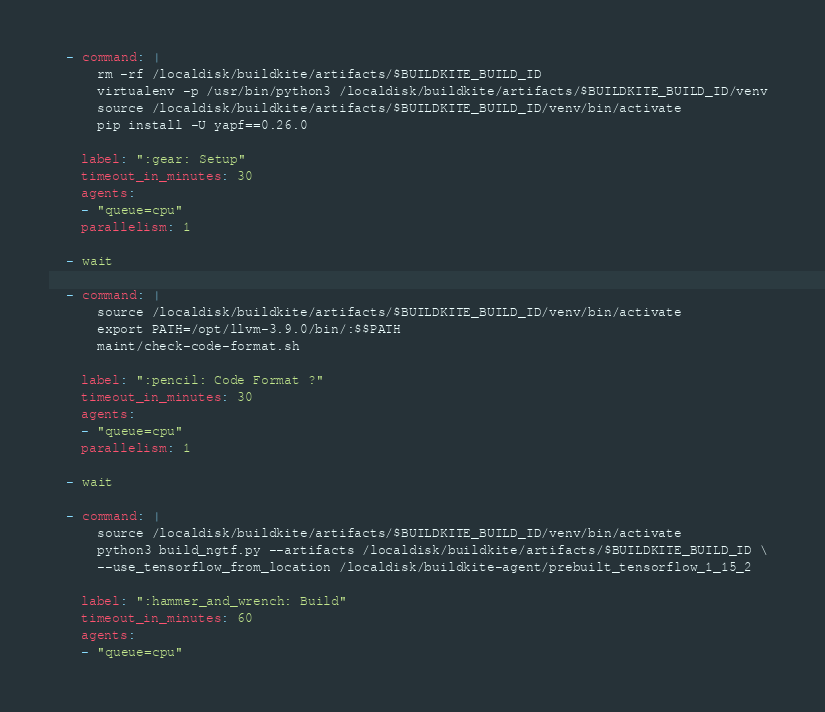<code> <loc_0><loc_0><loc_500><loc_500><_YAML_>  - command: |
      rm -rf /localdisk/buildkite/artifacts/$BUILDKITE_BUILD_ID
      virtualenv -p /usr/bin/python3 /localdisk/buildkite/artifacts/$BUILDKITE_BUILD_ID/venv 
      source /localdisk/buildkite/artifacts/$BUILDKITE_BUILD_ID/venv/bin/activate 
      pip install -U yapf==0.26.0
      
    label: ":gear: Setup"
    timeout_in_minutes: 30
    agents:
    - "queue=cpu"
    parallelism: 1

  - wait

  - command: |
      source /localdisk/buildkite/artifacts/$BUILDKITE_BUILD_ID/venv/bin/activate 
      export PATH=/opt/llvm-3.9.0/bin/:$$PATH 
      maint/check-code-format.sh
      
    label: ":pencil: Code Format ?"
    timeout_in_minutes: 30
    agents:
    - "queue=cpu"
    parallelism: 1

  - wait

  - command: |
      source /localdisk/buildkite/artifacts/$BUILDKITE_BUILD_ID/venv/bin/activate 
      python3 build_ngtf.py --artifacts /localdisk/buildkite/artifacts/$BUILDKITE_BUILD_ID \
      --use_tensorflow_from_location /localdisk/buildkite-agent/prebuilt_tensorflow_1_15_2
      
    label: ":hammer_and_wrench: Build"
    timeout_in_minutes: 60
    agents:
    - "queue=cpu"</code> 